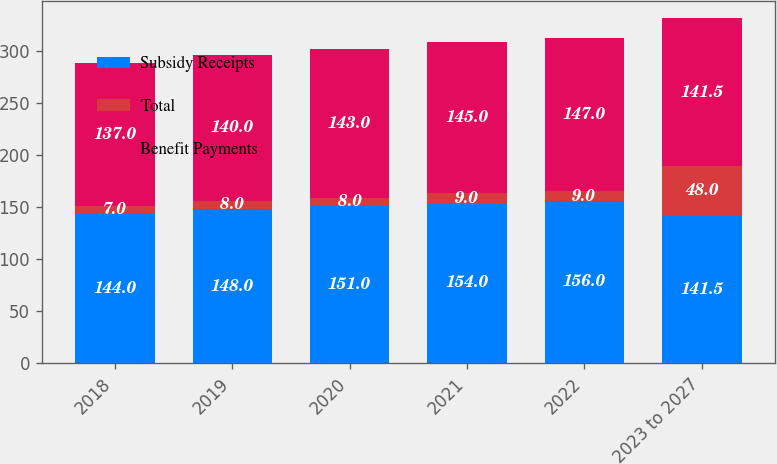<chart> <loc_0><loc_0><loc_500><loc_500><stacked_bar_chart><ecel><fcel>2018<fcel>2019<fcel>2020<fcel>2021<fcel>2022<fcel>2023 to 2027<nl><fcel>Subsidy Receipts<fcel>144<fcel>148<fcel>151<fcel>154<fcel>156<fcel>141.5<nl><fcel>Total<fcel>7<fcel>8<fcel>8<fcel>9<fcel>9<fcel>48<nl><fcel>Benefit Payments<fcel>137<fcel>140<fcel>143<fcel>145<fcel>147<fcel>141.5<nl></chart> 